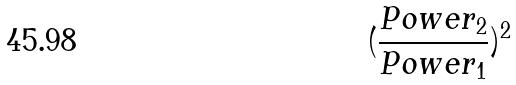<formula> <loc_0><loc_0><loc_500><loc_500>( \frac { P o w e r _ { 2 } } { P o w e r _ { 1 } } ) ^ { 2 }</formula> 